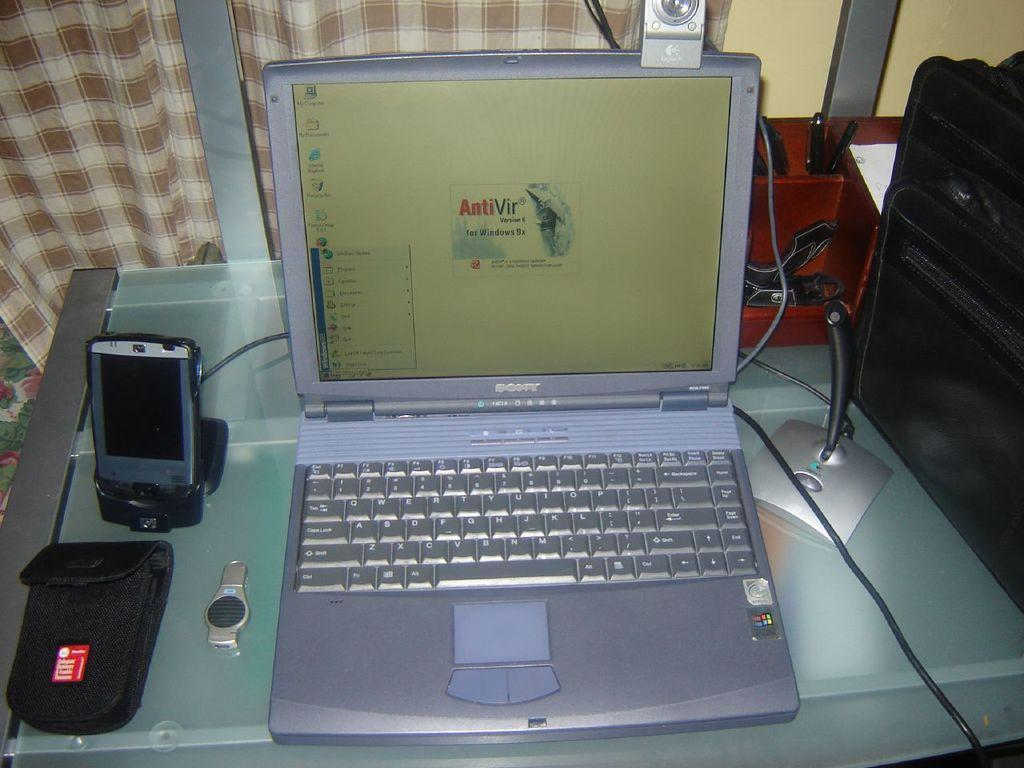<image>
Relay a brief, clear account of the picture shown. A Sony laptop with AntiVir version 6 for windows 9x on the screen. 